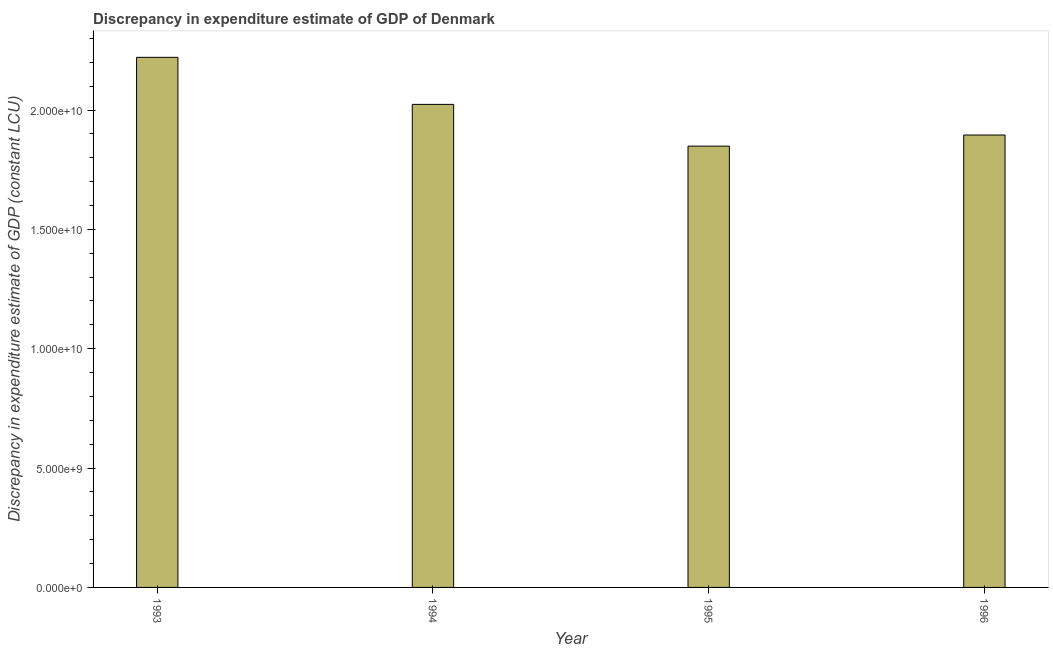What is the title of the graph?
Offer a very short reply. Discrepancy in expenditure estimate of GDP of Denmark. What is the label or title of the Y-axis?
Make the answer very short. Discrepancy in expenditure estimate of GDP (constant LCU). What is the discrepancy in expenditure estimate of gdp in 1996?
Your answer should be compact. 1.90e+1. Across all years, what is the maximum discrepancy in expenditure estimate of gdp?
Offer a very short reply. 2.22e+1. Across all years, what is the minimum discrepancy in expenditure estimate of gdp?
Make the answer very short. 1.85e+1. In which year was the discrepancy in expenditure estimate of gdp maximum?
Your answer should be compact. 1993. What is the sum of the discrepancy in expenditure estimate of gdp?
Your answer should be very brief. 7.99e+1. What is the difference between the discrepancy in expenditure estimate of gdp in 1995 and 1996?
Provide a succinct answer. -4.65e+08. What is the average discrepancy in expenditure estimate of gdp per year?
Make the answer very short. 2.00e+1. What is the median discrepancy in expenditure estimate of gdp?
Your response must be concise. 1.96e+1. What is the ratio of the discrepancy in expenditure estimate of gdp in 1993 to that in 1994?
Offer a very short reply. 1.1. Is the difference between the discrepancy in expenditure estimate of gdp in 1994 and 1996 greater than the difference between any two years?
Ensure brevity in your answer.  No. What is the difference between the highest and the second highest discrepancy in expenditure estimate of gdp?
Your answer should be very brief. 1.97e+09. What is the difference between the highest and the lowest discrepancy in expenditure estimate of gdp?
Your answer should be very brief. 3.72e+09. How many bars are there?
Give a very brief answer. 4. What is the difference between two consecutive major ticks on the Y-axis?
Offer a terse response. 5.00e+09. Are the values on the major ticks of Y-axis written in scientific E-notation?
Your answer should be compact. Yes. What is the Discrepancy in expenditure estimate of GDP (constant LCU) in 1993?
Provide a short and direct response. 2.22e+1. What is the Discrepancy in expenditure estimate of GDP (constant LCU) in 1994?
Offer a very short reply. 2.02e+1. What is the Discrepancy in expenditure estimate of GDP (constant LCU) in 1995?
Provide a succinct answer. 1.85e+1. What is the Discrepancy in expenditure estimate of GDP (constant LCU) in 1996?
Offer a very short reply. 1.90e+1. What is the difference between the Discrepancy in expenditure estimate of GDP (constant LCU) in 1993 and 1994?
Your response must be concise. 1.97e+09. What is the difference between the Discrepancy in expenditure estimate of GDP (constant LCU) in 1993 and 1995?
Your answer should be very brief. 3.72e+09. What is the difference between the Discrepancy in expenditure estimate of GDP (constant LCU) in 1993 and 1996?
Provide a succinct answer. 3.26e+09. What is the difference between the Discrepancy in expenditure estimate of GDP (constant LCU) in 1994 and 1995?
Provide a succinct answer. 1.75e+09. What is the difference between the Discrepancy in expenditure estimate of GDP (constant LCU) in 1994 and 1996?
Provide a succinct answer. 1.28e+09. What is the difference between the Discrepancy in expenditure estimate of GDP (constant LCU) in 1995 and 1996?
Make the answer very short. -4.65e+08. What is the ratio of the Discrepancy in expenditure estimate of GDP (constant LCU) in 1993 to that in 1994?
Give a very brief answer. 1.1. What is the ratio of the Discrepancy in expenditure estimate of GDP (constant LCU) in 1993 to that in 1995?
Provide a short and direct response. 1.2. What is the ratio of the Discrepancy in expenditure estimate of GDP (constant LCU) in 1993 to that in 1996?
Keep it short and to the point. 1.17. What is the ratio of the Discrepancy in expenditure estimate of GDP (constant LCU) in 1994 to that in 1995?
Your answer should be compact. 1.09. What is the ratio of the Discrepancy in expenditure estimate of GDP (constant LCU) in 1994 to that in 1996?
Your answer should be very brief. 1.07. What is the ratio of the Discrepancy in expenditure estimate of GDP (constant LCU) in 1995 to that in 1996?
Your answer should be very brief. 0.97. 